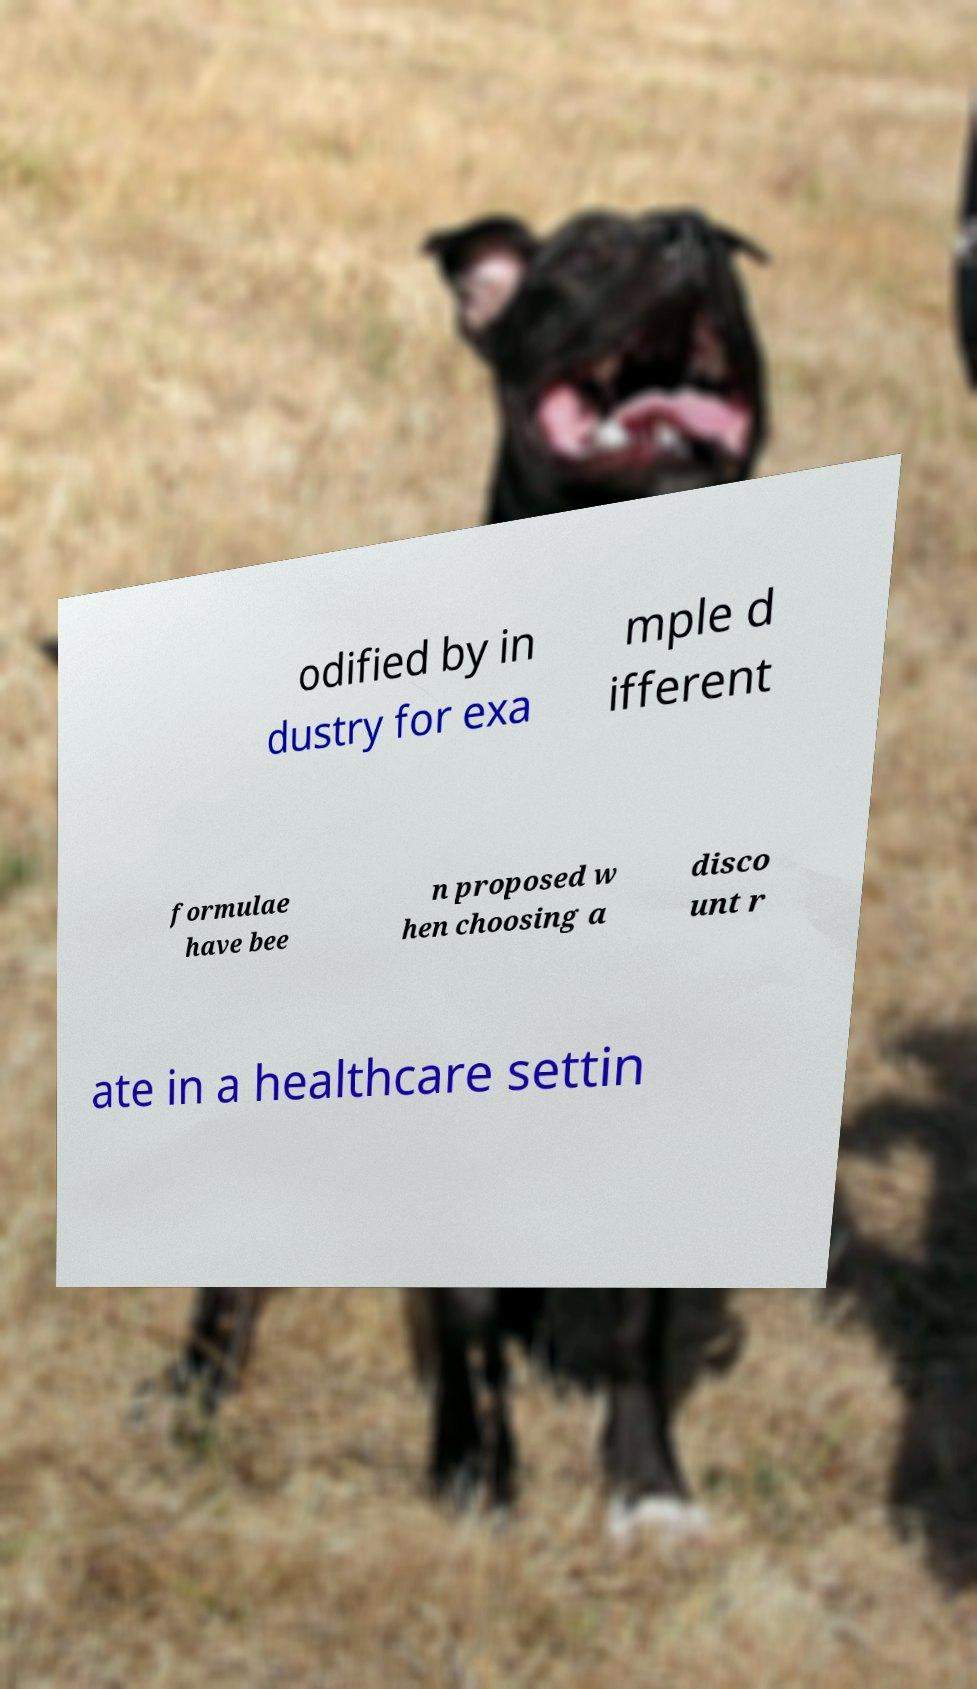What messages or text are displayed in this image? I need them in a readable, typed format. odified by in dustry for exa mple d ifferent formulae have bee n proposed w hen choosing a disco unt r ate in a healthcare settin 